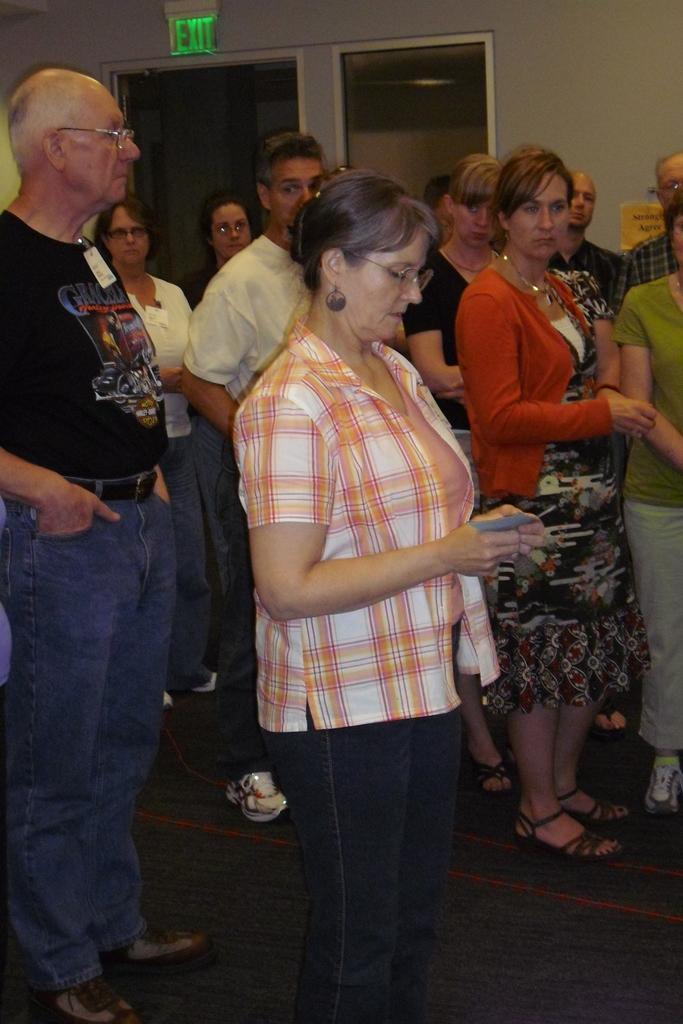Please provide a concise description of this image. In this picture we can see a group of people standing on the floor and some people wore spectacles and in the background we can see the wall, name board, glass. 